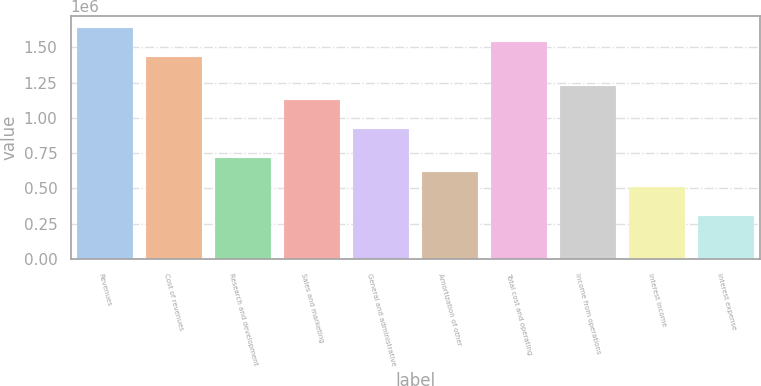Convert chart to OTSL. <chart><loc_0><loc_0><loc_500><loc_500><bar_chart><fcel>Revenues<fcel>Cost of revenues<fcel>Research and development<fcel>Sales and marketing<fcel>General and administrative<fcel>Amortization of other<fcel>Total cost and operating<fcel>Income from operations<fcel>Interest income<fcel>Interest expense<nl><fcel>1.63774e+06<fcel>1.43302e+06<fcel>716510<fcel>1.12594e+06<fcel>921227<fcel>614152<fcel>1.53538e+06<fcel>1.2283e+06<fcel>511793<fcel>307076<nl></chart> 